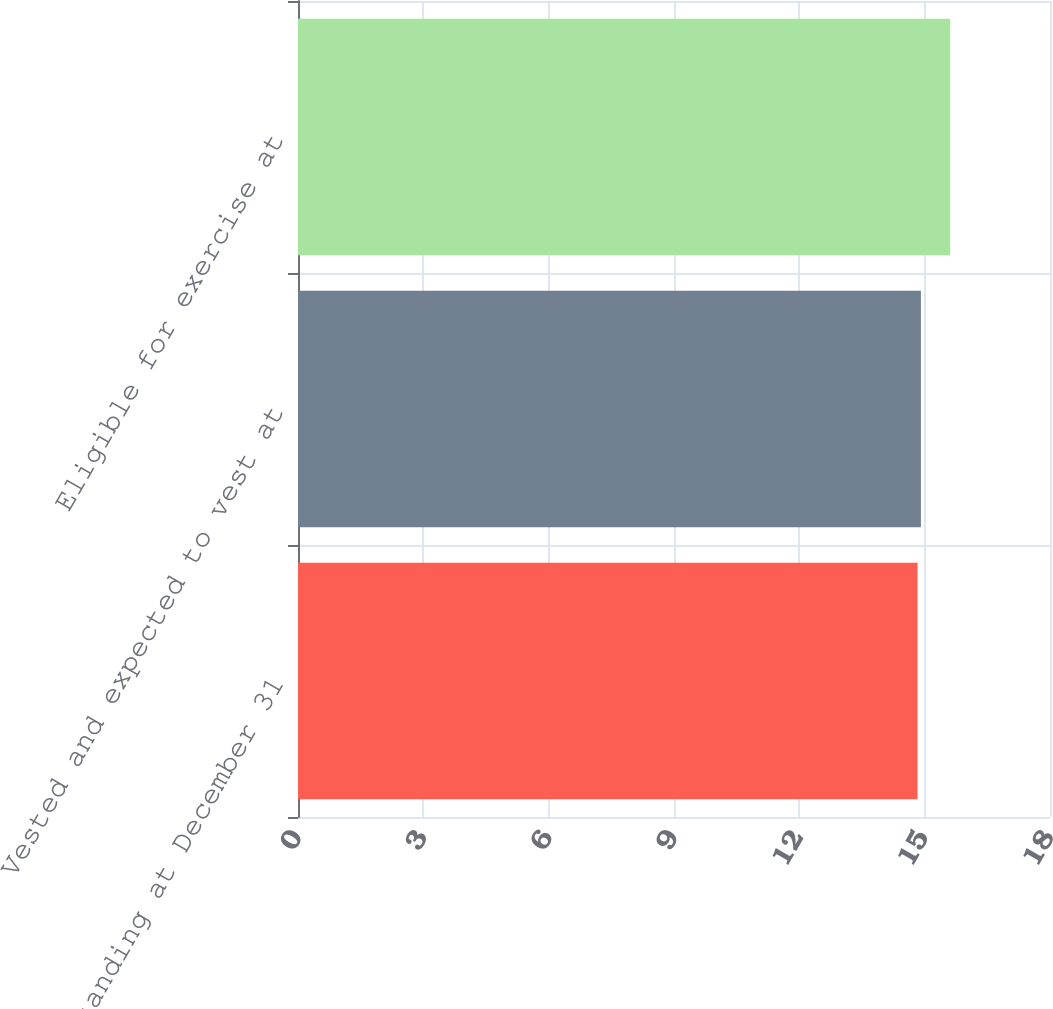Convert chart. <chart><loc_0><loc_0><loc_500><loc_500><bar_chart><fcel>Outstanding at December 31<fcel>Vested and expected to vest at<fcel>Eligible for exercise at<nl><fcel>14.83<fcel>14.91<fcel>15.61<nl></chart> 